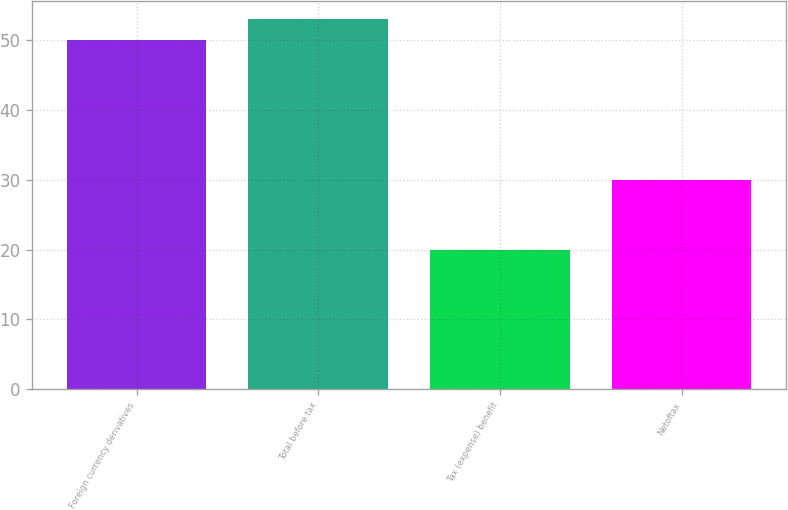Convert chart to OTSL. <chart><loc_0><loc_0><loc_500><loc_500><bar_chart><fcel>Foreign currency derivatives<fcel>Total before tax<fcel>Tax (expense) benefit<fcel>Netoftax<nl><fcel>50<fcel>53<fcel>20<fcel>30<nl></chart> 